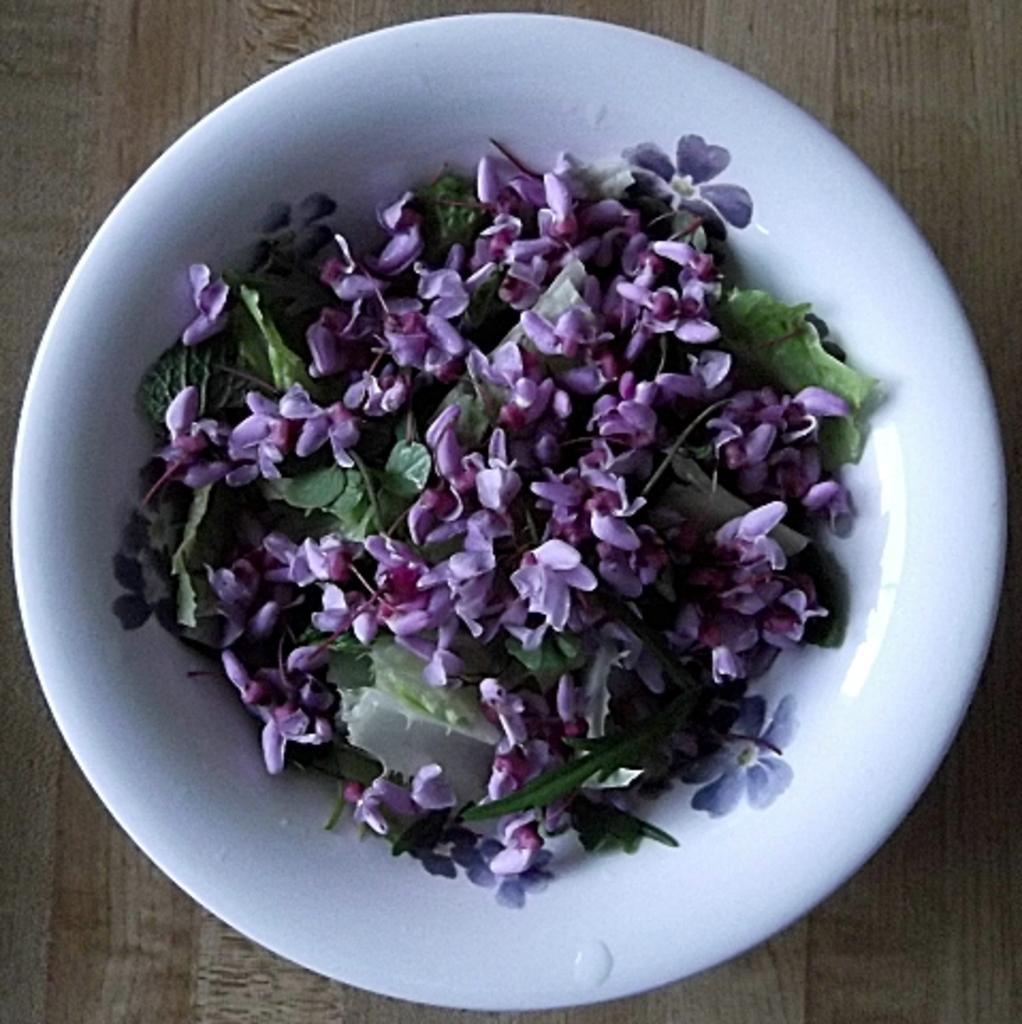In one or two sentences, can you explain what this image depicts? On a surface there is a bowl and in a bowl we can see leaves and flowers. 